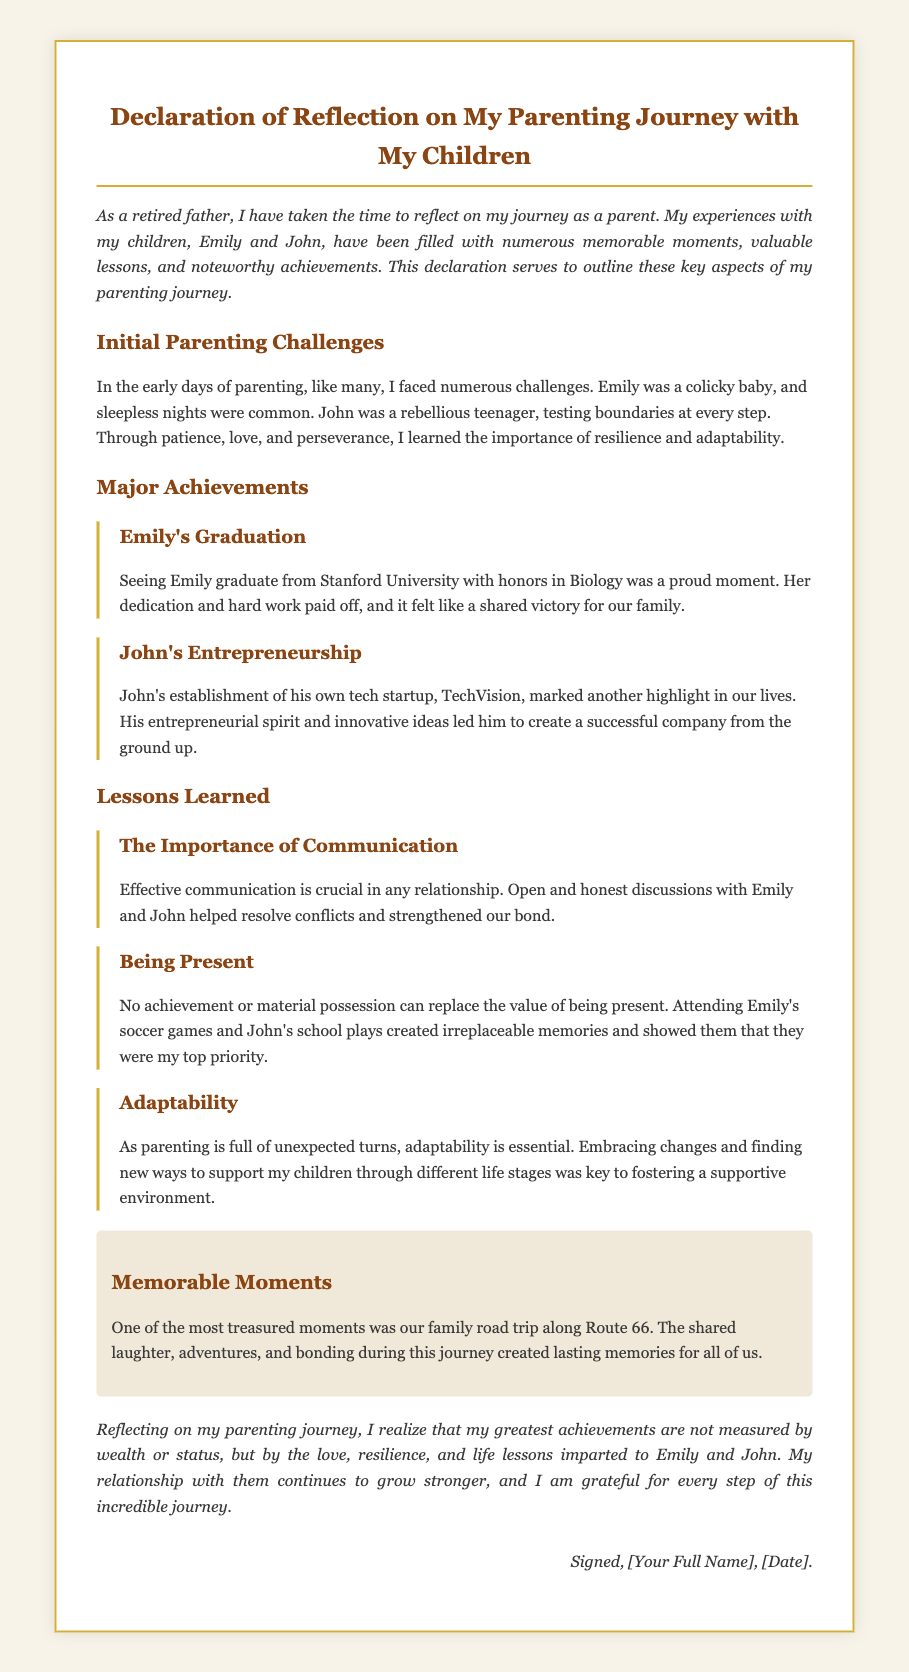What university did Emily graduate from? The document states that Emily graduated from Stanford University.
Answer: Stanford University What subject did Emily study? The document mentions that Emily graduated with honors in Biology.
Answer: Biology What is the name of John's startup? The document indicates that John's startup is called TechVision.
Answer: TechVision What lesson emphasizes the need for open discussions? The document highlights the importance of effective communication as crucial in any relationship.
Answer: The Importance of Communication What was a memorable moment mentioned in the document? The document describes a family road trip along Route 66 as one of the most treasured moments.
Answer: Family road trip along Route 66 How did the author describe the qualities measured in achievements? The document states that achievements are not measured by wealth or status but by love, resilience, and life lessons.
Answer: Love, resilience, and life lessons What is a key factor to adaptability in parenting, according to the document? The document emphasizes that embracing changes is essential for adaptability in parenting.
Answer: Embracing changes What personal reflection theme does the author conclude with? The conclusion conveys the theme of gratitude for the parenting journey and the strengthening relationship with his children.
Answer: Gratitude for the parenting journey 